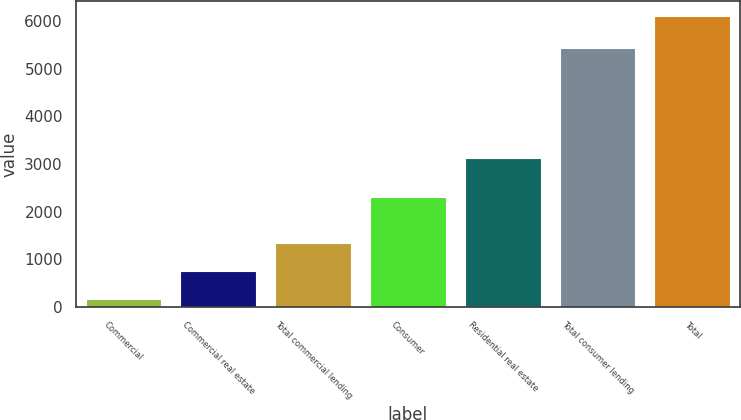Convert chart to OTSL. <chart><loc_0><loc_0><loc_500><loc_500><bar_chart><fcel>Commercial<fcel>Commercial real estate<fcel>Total commercial lending<fcel>Consumer<fcel>Residential real estate<fcel>Total consumer lending<fcel>Total<nl><fcel>157<fcel>751.9<fcel>1346.8<fcel>2312<fcel>3121<fcel>5433<fcel>6106<nl></chart> 